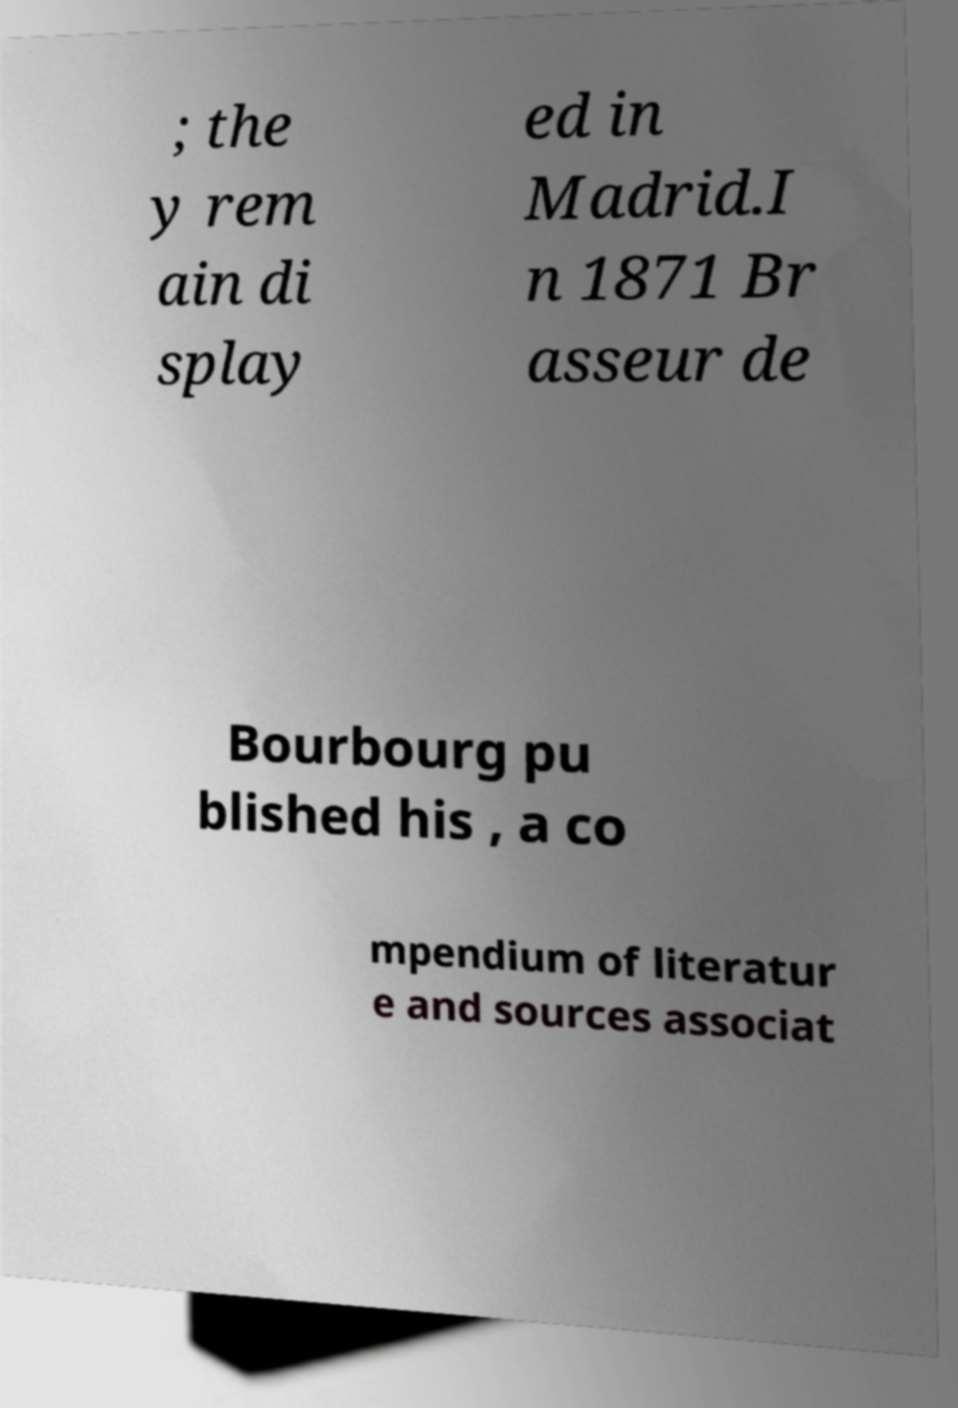Can you read and provide the text displayed in the image?This photo seems to have some interesting text. Can you extract and type it out for me? ; the y rem ain di splay ed in Madrid.I n 1871 Br asseur de Bourbourg pu blished his , a co mpendium of literatur e and sources associat 